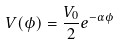Convert formula to latex. <formula><loc_0><loc_0><loc_500><loc_500>V ( \phi ) = \frac { V _ { 0 } } { 2 } e ^ { - \alpha \phi }</formula> 